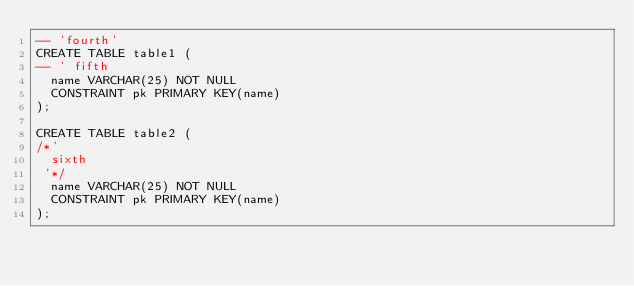Convert code to text. <code><loc_0><loc_0><loc_500><loc_500><_SQL_>-- 'fourth'
CREATE TABLE table1 (
-- ' fifth
  name VARCHAR(25) NOT NULL
  CONSTRAINT pk PRIMARY KEY(name)
);

CREATE TABLE table2 (
/*'
  sixth
 '*/
  name VARCHAR(25) NOT NULL
  CONSTRAINT pk PRIMARY KEY(name)
);
</code> 